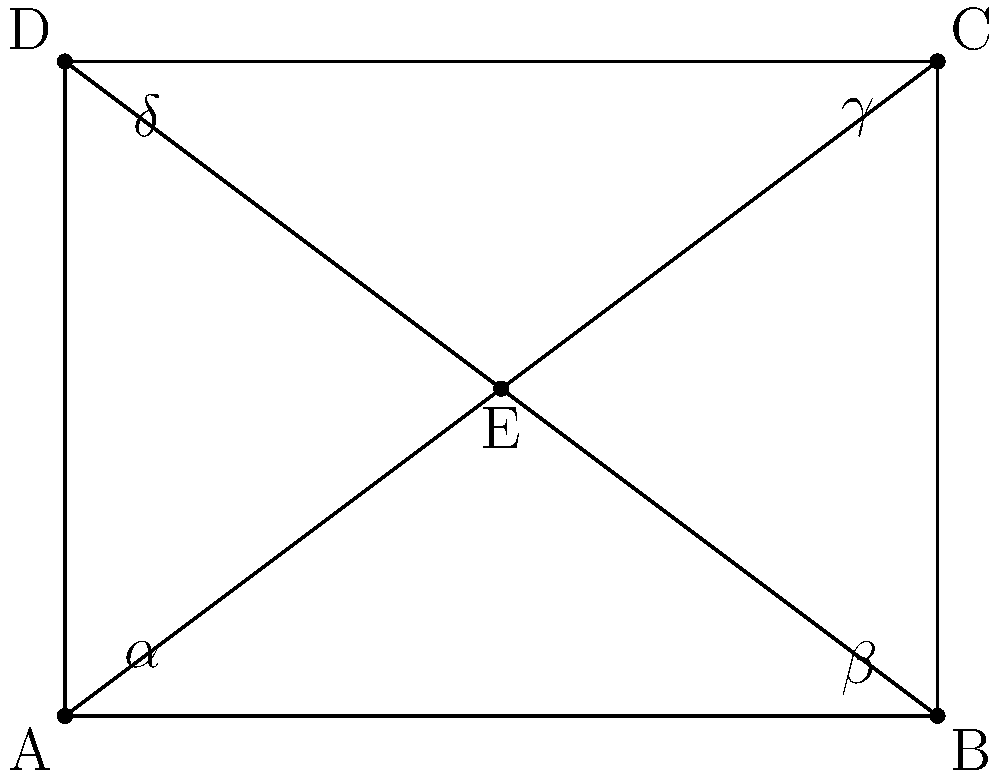In designing an optimal surveillance camera layout for a high-security vault, you notice that the room has a rectangular shape with a central point where all cameras converge. If angles $\alpha$ and $\gamma$ are congruent, which other pair of angles must also be congruent to ensure complete coverage without blind spots? To solve this problem, let's follow these steps:

1) In a rectangle, opposite angles are always congruent. This means that $\angle DAB = \angle BCD$ and $\angle ABC = \angle CDA$.

2) The central point E creates four triangles: AEB, BEC, CED, and DEA.

3) We're told that $\angle AEB$ ($\alpha$) and $\angle CED$ ($\gamma$) are congruent.

4) In a rectangle, diagonals bisect each other. This means that AE = EC and BE = ED.

5) Given that $\alpha = \gamma$ and the sides adjacent to these angles are equal (AE = EC, BE = ED), we can conclude that triangles AEB and CED are congruent by the AAS (Angle-Angle-Side) congruence criterion.

6) When two triangles are congruent, all their corresponding parts are congruent. This means that $\angle ABE$ ($\beta$) must be congruent to $\angle DCE$ ($\delta$).

7) Therefore, to ensure complete coverage without blind spots, angles $\beta$ and $\delta$ must be congruent.
Answer: $\beta$ and $\delta$ 